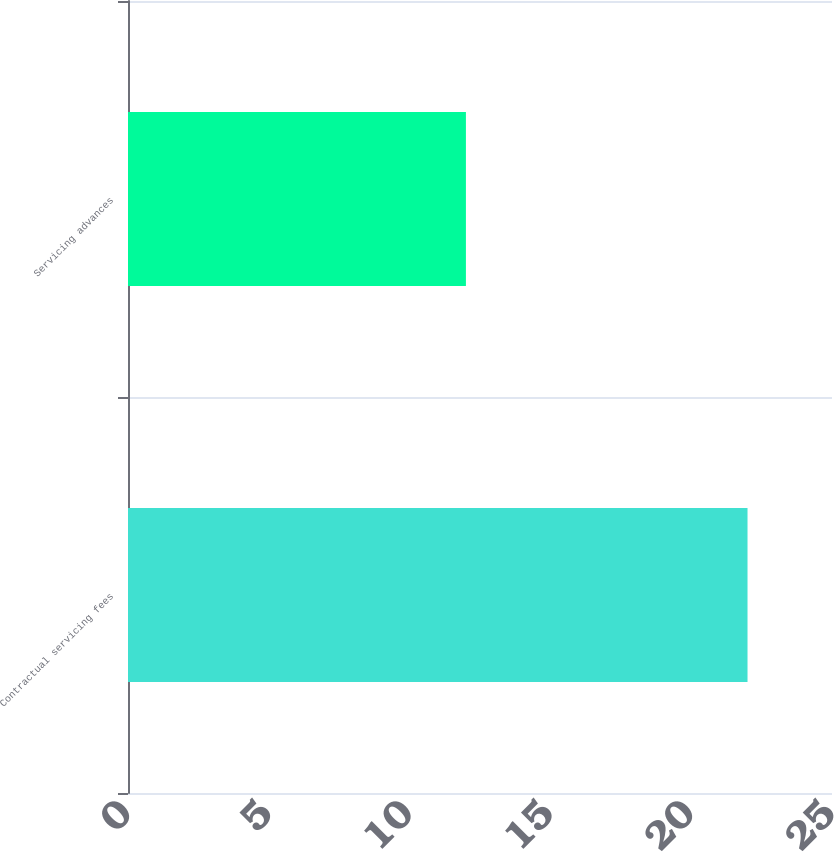Convert chart to OTSL. <chart><loc_0><loc_0><loc_500><loc_500><bar_chart><fcel>Contractual servicing fees<fcel>Servicing advances<nl><fcel>22<fcel>12<nl></chart> 